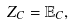Convert formula to latex. <formula><loc_0><loc_0><loc_500><loc_500>Z _ { C } = { \mathbb { E } } _ { C } ,</formula> 